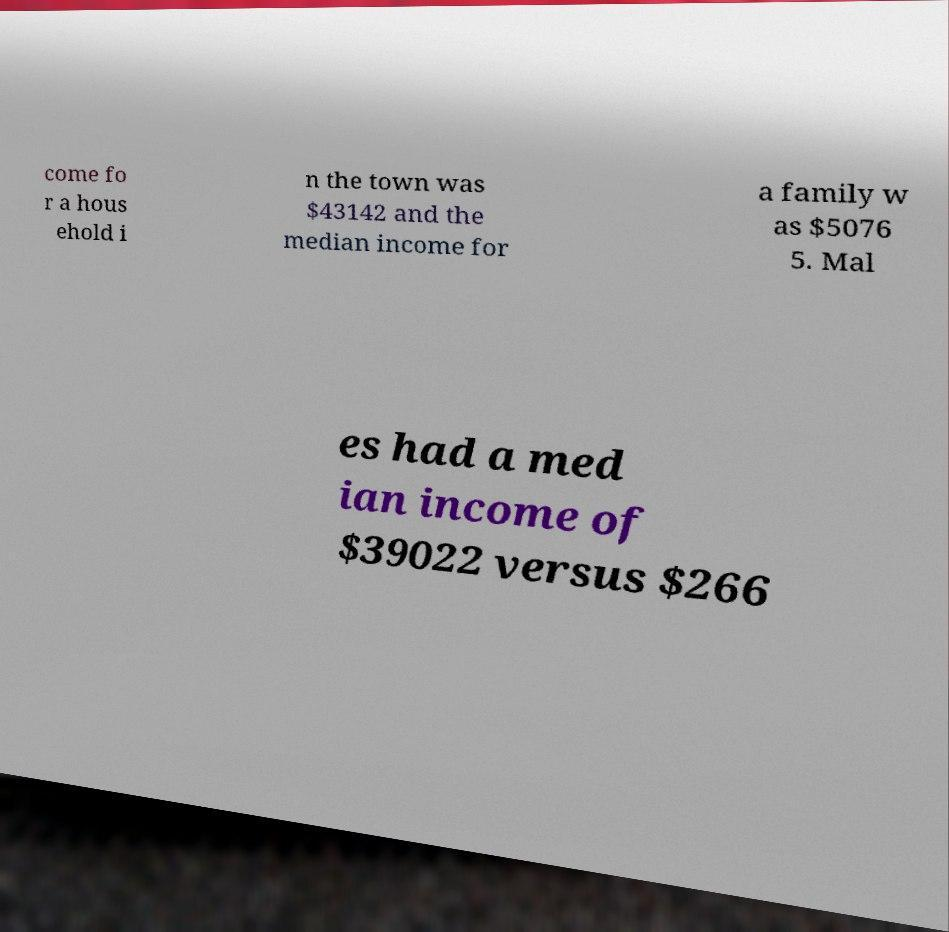Can you read and provide the text displayed in the image?This photo seems to have some interesting text. Can you extract and type it out for me? come fo r a hous ehold i n the town was $43142 and the median income for a family w as $5076 5. Mal es had a med ian income of $39022 versus $266 